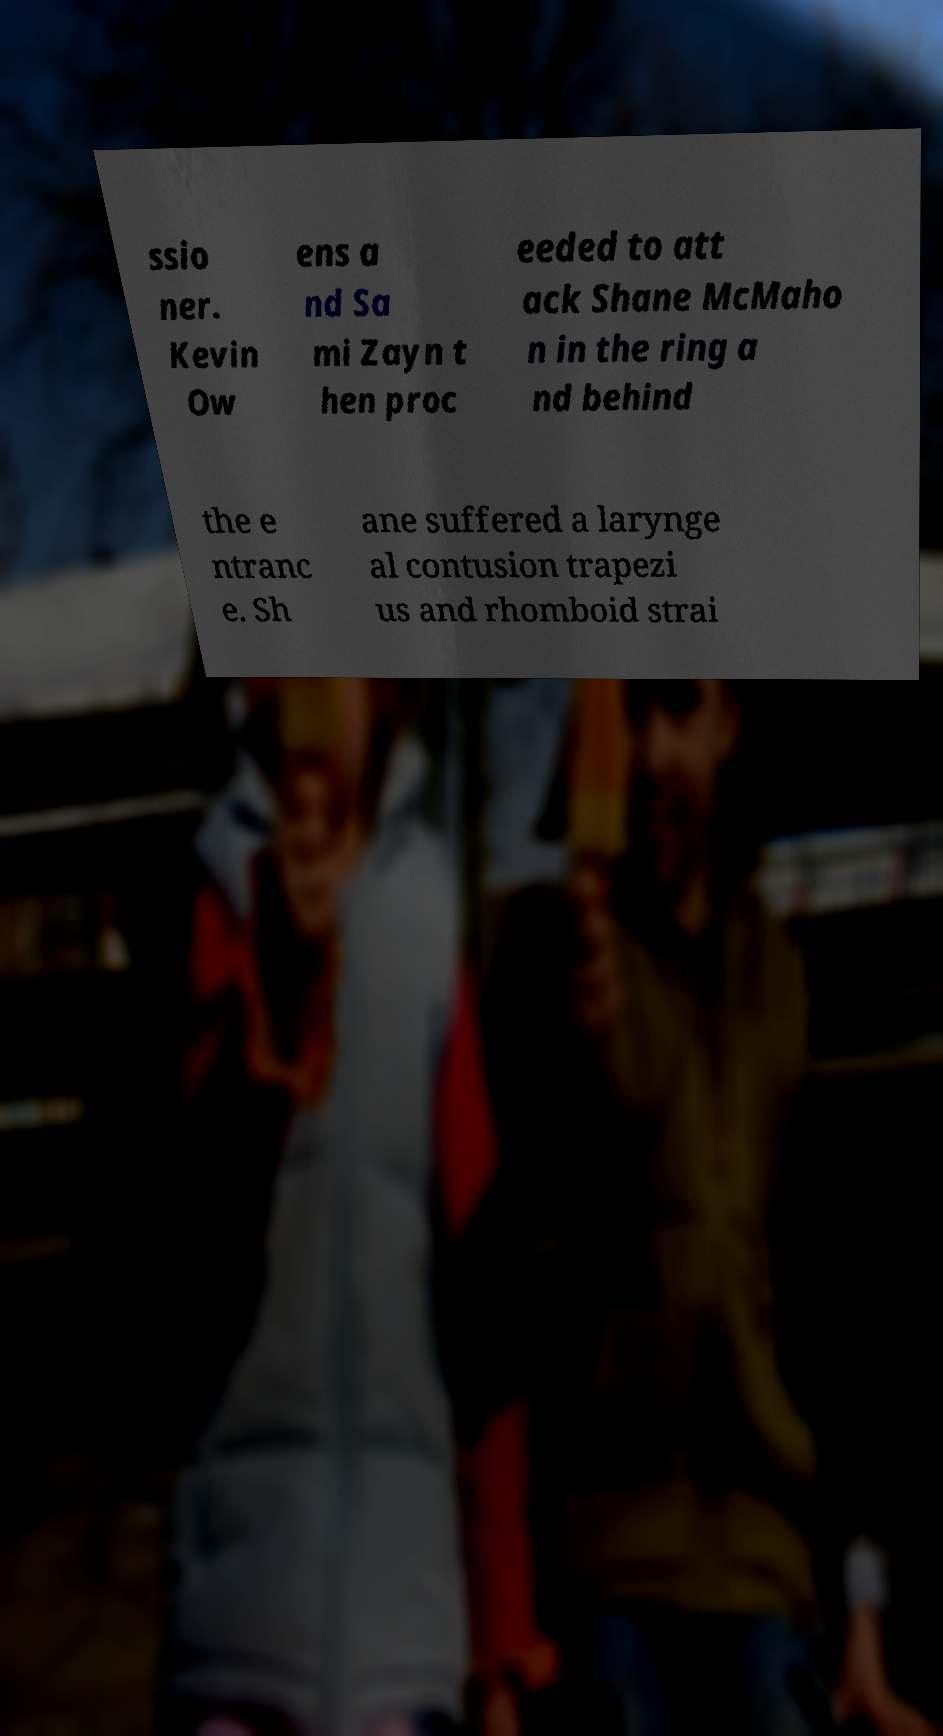Could you extract and type out the text from this image? ssio ner. Kevin Ow ens a nd Sa mi Zayn t hen proc eeded to att ack Shane McMaho n in the ring a nd behind the e ntranc e. Sh ane suffered a larynge al contusion trapezi us and rhomboid strai 